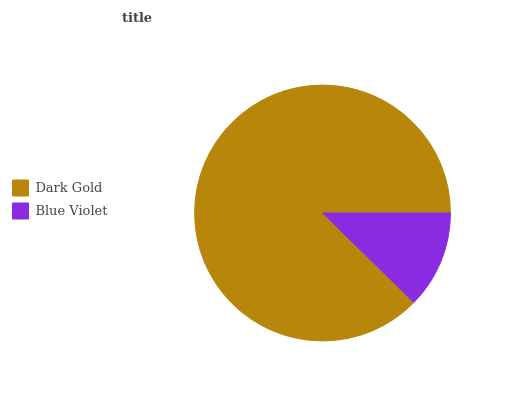Is Blue Violet the minimum?
Answer yes or no. Yes. Is Dark Gold the maximum?
Answer yes or no. Yes. Is Blue Violet the maximum?
Answer yes or no. No. Is Dark Gold greater than Blue Violet?
Answer yes or no. Yes. Is Blue Violet less than Dark Gold?
Answer yes or no. Yes. Is Blue Violet greater than Dark Gold?
Answer yes or no. No. Is Dark Gold less than Blue Violet?
Answer yes or no. No. Is Dark Gold the high median?
Answer yes or no. Yes. Is Blue Violet the low median?
Answer yes or no. Yes. Is Blue Violet the high median?
Answer yes or no. No. Is Dark Gold the low median?
Answer yes or no. No. 